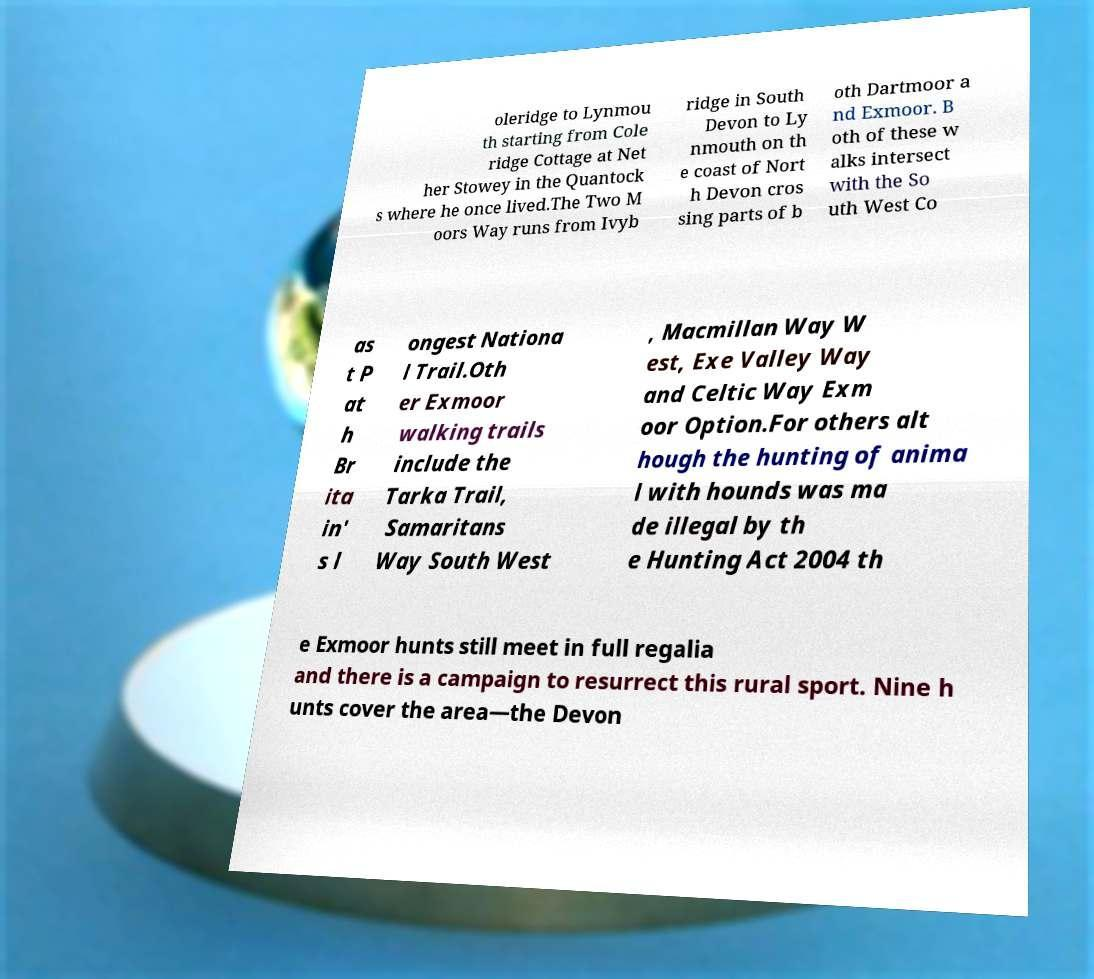Can you read and provide the text displayed in the image?This photo seems to have some interesting text. Can you extract and type it out for me? oleridge to Lynmou th starting from Cole ridge Cottage at Net her Stowey in the Quantock s where he once lived.The Two M oors Way runs from Ivyb ridge in South Devon to Ly nmouth on th e coast of Nort h Devon cros sing parts of b oth Dartmoor a nd Exmoor. B oth of these w alks intersect with the So uth West Co as t P at h Br ita in' s l ongest Nationa l Trail.Oth er Exmoor walking trails include the Tarka Trail, Samaritans Way South West , Macmillan Way W est, Exe Valley Way and Celtic Way Exm oor Option.For others alt hough the hunting of anima l with hounds was ma de illegal by th e Hunting Act 2004 th e Exmoor hunts still meet in full regalia and there is a campaign to resurrect this rural sport. Nine h unts cover the area—the Devon 